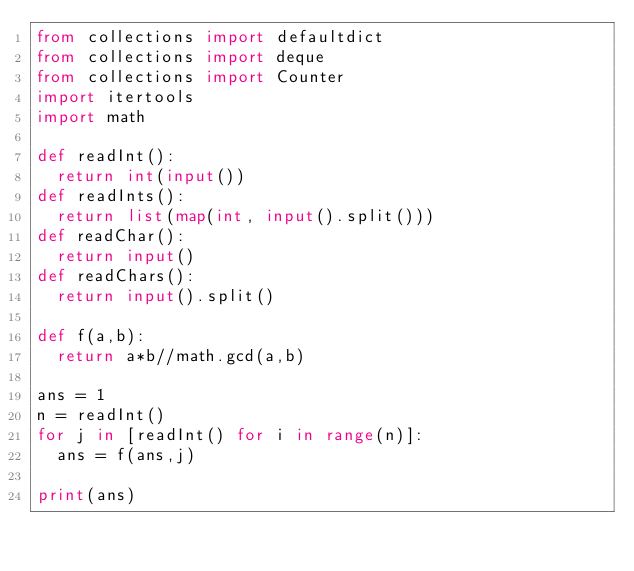<code> <loc_0><loc_0><loc_500><loc_500><_Python_>from collections import defaultdict
from collections import deque
from collections import Counter
import itertools
import math

def readInt():
  return int(input())
def readInts():
  return list(map(int, input().split()))
def readChar():
  return input()
def readChars():
  return input().split()

def f(a,b):
  return a*b//math.gcd(a,b)

ans = 1
n = readInt()
for j in [readInt() for i in range(n)]:
  ans = f(ans,j)

print(ans)</code> 